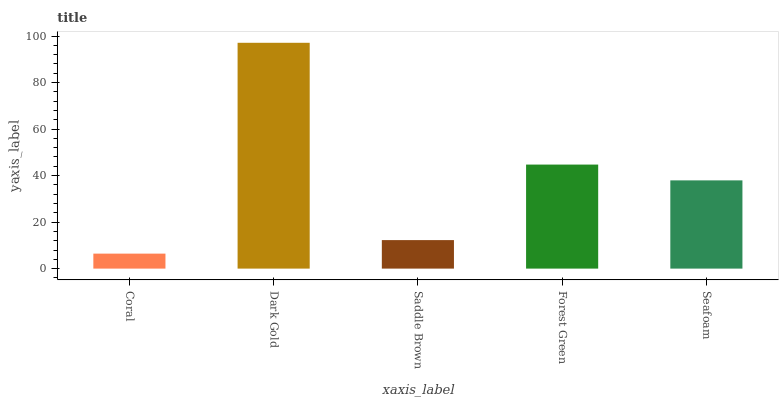Is Coral the minimum?
Answer yes or no. Yes. Is Dark Gold the maximum?
Answer yes or no. Yes. Is Saddle Brown the minimum?
Answer yes or no. No. Is Saddle Brown the maximum?
Answer yes or no. No. Is Dark Gold greater than Saddle Brown?
Answer yes or no. Yes. Is Saddle Brown less than Dark Gold?
Answer yes or no. Yes. Is Saddle Brown greater than Dark Gold?
Answer yes or no. No. Is Dark Gold less than Saddle Brown?
Answer yes or no. No. Is Seafoam the high median?
Answer yes or no. Yes. Is Seafoam the low median?
Answer yes or no. Yes. Is Saddle Brown the high median?
Answer yes or no. No. Is Coral the low median?
Answer yes or no. No. 